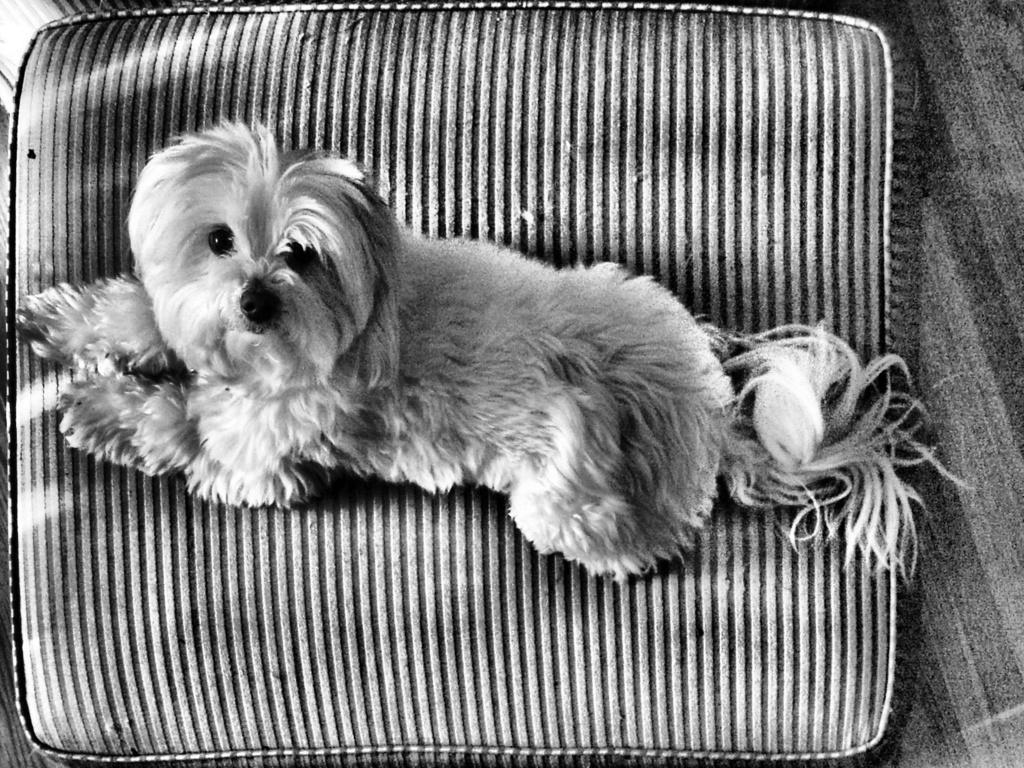Describe this image in one or two sentences. This is a black and white picture, we can see a dog on the pillow. 